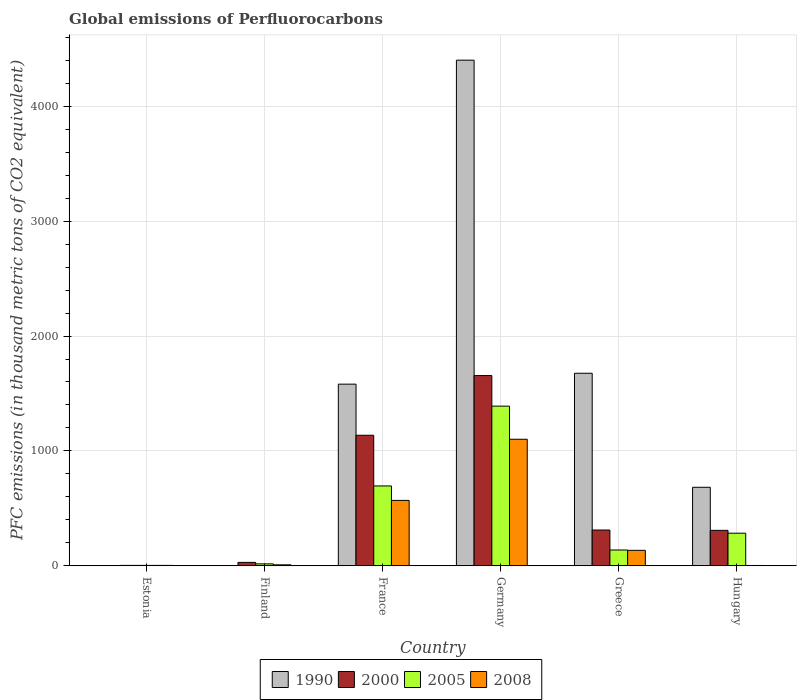How many bars are there on the 4th tick from the right?
Offer a terse response. 4. In how many cases, is the number of bars for a given country not equal to the number of legend labels?
Your response must be concise. 0. What is the global emissions of Perfluorocarbons in 2000 in Finland?
Your answer should be compact. 29.7. Across all countries, what is the maximum global emissions of Perfluorocarbons in 2008?
Offer a very short reply. 1101.4. Across all countries, what is the minimum global emissions of Perfluorocarbons in 2005?
Provide a short and direct response. 3.4. In which country was the global emissions of Perfluorocarbons in 2005 minimum?
Ensure brevity in your answer.  Estonia. What is the total global emissions of Perfluorocarbons in 2008 in the graph?
Your response must be concise. 1819.6. What is the difference between the global emissions of Perfluorocarbons in 2008 in France and that in Germany?
Provide a short and direct response. -532.2. What is the difference between the global emissions of Perfluorocarbons in 2000 in France and the global emissions of Perfluorocarbons in 1990 in Germany?
Make the answer very short. -3265. What is the average global emissions of Perfluorocarbons in 2005 per country?
Provide a succinct answer. 421.02. What is the difference between the global emissions of Perfluorocarbons of/in 2008 and global emissions of Perfluorocarbons of/in 2000 in Hungary?
Your response must be concise. -305.8. What is the ratio of the global emissions of Perfluorocarbons in 2005 in Germany to that in Greece?
Your answer should be very brief. 10.11. Is the global emissions of Perfluorocarbons in 2008 in Germany less than that in Hungary?
Give a very brief answer. No. Is the difference between the global emissions of Perfluorocarbons in 2008 in France and Greece greater than the difference between the global emissions of Perfluorocarbons in 2000 in France and Greece?
Make the answer very short. No. What is the difference between the highest and the second highest global emissions of Perfluorocarbons in 2005?
Keep it short and to the point. -1106. What is the difference between the highest and the lowest global emissions of Perfluorocarbons in 2000?
Keep it short and to the point. 1652.4. In how many countries, is the global emissions of Perfluorocarbons in 2000 greater than the average global emissions of Perfluorocarbons in 2000 taken over all countries?
Offer a terse response. 2. Is the sum of the global emissions of Perfluorocarbons in 2008 in Finland and France greater than the maximum global emissions of Perfluorocarbons in 2000 across all countries?
Your answer should be compact. No. What does the 2nd bar from the left in Hungary represents?
Your response must be concise. 2000. Is it the case that in every country, the sum of the global emissions of Perfluorocarbons in 2005 and global emissions of Perfluorocarbons in 2008 is greater than the global emissions of Perfluorocarbons in 2000?
Your answer should be very brief. No. Are all the bars in the graph horizontal?
Give a very brief answer. No. Are the values on the major ticks of Y-axis written in scientific E-notation?
Your answer should be compact. No. Does the graph contain any zero values?
Ensure brevity in your answer.  No. Does the graph contain grids?
Provide a succinct answer. Yes. How many legend labels are there?
Offer a very short reply. 4. What is the title of the graph?
Ensure brevity in your answer.  Global emissions of Perfluorocarbons. Does "1988" appear as one of the legend labels in the graph?
Give a very brief answer. No. What is the label or title of the Y-axis?
Ensure brevity in your answer.  PFC emissions (in thousand metric tons of CO2 equivalent). What is the PFC emissions (in thousand metric tons of CO2 equivalent) in 2000 in Estonia?
Your response must be concise. 3.5. What is the PFC emissions (in thousand metric tons of CO2 equivalent) in 2005 in Estonia?
Keep it short and to the point. 3.4. What is the PFC emissions (in thousand metric tons of CO2 equivalent) of 2008 in Estonia?
Keep it short and to the point. 3.4. What is the PFC emissions (in thousand metric tons of CO2 equivalent) of 2000 in Finland?
Offer a very short reply. 29.7. What is the PFC emissions (in thousand metric tons of CO2 equivalent) in 1990 in France?
Give a very brief answer. 1581.1. What is the PFC emissions (in thousand metric tons of CO2 equivalent) of 2000 in France?
Your answer should be compact. 1136.3. What is the PFC emissions (in thousand metric tons of CO2 equivalent) of 2005 in France?
Offer a very short reply. 695.1. What is the PFC emissions (in thousand metric tons of CO2 equivalent) of 2008 in France?
Ensure brevity in your answer.  569.2. What is the PFC emissions (in thousand metric tons of CO2 equivalent) in 1990 in Germany?
Offer a terse response. 4401.3. What is the PFC emissions (in thousand metric tons of CO2 equivalent) of 2000 in Germany?
Offer a very short reply. 1655.9. What is the PFC emissions (in thousand metric tons of CO2 equivalent) in 2005 in Germany?
Make the answer very short. 1389.7. What is the PFC emissions (in thousand metric tons of CO2 equivalent) of 2008 in Germany?
Provide a succinct answer. 1101.4. What is the PFC emissions (in thousand metric tons of CO2 equivalent) of 1990 in Greece?
Keep it short and to the point. 1675.9. What is the PFC emissions (in thousand metric tons of CO2 equivalent) of 2000 in Greece?
Provide a succinct answer. 311.3. What is the PFC emissions (in thousand metric tons of CO2 equivalent) of 2005 in Greece?
Ensure brevity in your answer.  137.5. What is the PFC emissions (in thousand metric tons of CO2 equivalent) in 2008 in Greece?
Offer a very short reply. 134.5. What is the PFC emissions (in thousand metric tons of CO2 equivalent) in 1990 in Hungary?
Your answer should be compact. 683.3. What is the PFC emissions (in thousand metric tons of CO2 equivalent) of 2000 in Hungary?
Make the answer very short. 308.5. What is the PFC emissions (in thousand metric tons of CO2 equivalent) in 2005 in Hungary?
Your answer should be very brief. 283.7. Across all countries, what is the maximum PFC emissions (in thousand metric tons of CO2 equivalent) in 1990?
Give a very brief answer. 4401.3. Across all countries, what is the maximum PFC emissions (in thousand metric tons of CO2 equivalent) in 2000?
Provide a succinct answer. 1655.9. Across all countries, what is the maximum PFC emissions (in thousand metric tons of CO2 equivalent) in 2005?
Provide a succinct answer. 1389.7. Across all countries, what is the maximum PFC emissions (in thousand metric tons of CO2 equivalent) of 2008?
Your answer should be very brief. 1101.4. Across all countries, what is the minimum PFC emissions (in thousand metric tons of CO2 equivalent) of 1990?
Offer a very short reply. 0.5. Across all countries, what is the minimum PFC emissions (in thousand metric tons of CO2 equivalent) of 2005?
Give a very brief answer. 3.4. Across all countries, what is the minimum PFC emissions (in thousand metric tons of CO2 equivalent) in 2008?
Make the answer very short. 2.7. What is the total PFC emissions (in thousand metric tons of CO2 equivalent) in 1990 in the graph?
Your answer should be compact. 8343.8. What is the total PFC emissions (in thousand metric tons of CO2 equivalent) in 2000 in the graph?
Keep it short and to the point. 3445.2. What is the total PFC emissions (in thousand metric tons of CO2 equivalent) of 2005 in the graph?
Make the answer very short. 2526.1. What is the total PFC emissions (in thousand metric tons of CO2 equivalent) of 2008 in the graph?
Make the answer very short. 1819.6. What is the difference between the PFC emissions (in thousand metric tons of CO2 equivalent) in 2000 in Estonia and that in Finland?
Make the answer very short. -26.2. What is the difference between the PFC emissions (in thousand metric tons of CO2 equivalent) of 1990 in Estonia and that in France?
Provide a succinct answer. -1580.6. What is the difference between the PFC emissions (in thousand metric tons of CO2 equivalent) of 2000 in Estonia and that in France?
Your response must be concise. -1132.8. What is the difference between the PFC emissions (in thousand metric tons of CO2 equivalent) in 2005 in Estonia and that in France?
Offer a terse response. -691.7. What is the difference between the PFC emissions (in thousand metric tons of CO2 equivalent) in 2008 in Estonia and that in France?
Offer a terse response. -565.8. What is the difference between the PFC emissions (in thousand metric tons of CO2 equivalent) in 1990 in Estonia and that in Germany?
Your answer should be very brief. -4400.8. What is the difference between the PFC emissions (in thousand metric tons of CO2 equivalent) of 2000 in Estonia and that in Germany?
Keep it short and to the point. -1652.4. What is the difference between the PFC emissions (in thousand metric tons of CO2 equivalent) of 2005 in Estonia and that in Germany?
Keep it short and to the point. -1386.3. What is the difference between the PFC emissions (in thousand metric tons of CO2 equivalent) in 2008 in Estonia and that in Germany?
Your answer should be compact. -1098. What is the difference between the PFC emissions (in thousand metric tons of CO2 equivalent) of 1990 in Estonia and that in Greece?
Ensure brevity in your answer.  -1675.4. What is the difference between the PFC emissions (in thousand metric tons of CO2 equivalent) in 2000 in Estonia and that in Greece?
Keep it short and to the point. -307.8. What is the difference between the PFC emissions (in thousand metric tons of CO2 equivalent) in 2005 in Estonia and that in Greece?
Provide a succinct answer. -134.1. What is the difference between the PFC emissions (in thousand metric tons of CO2 equivalent) in 2008 in Estonia and that in Greece?
Your answer should be very brief. -131.1. What is the difference between the PFC emissions (in thousand metric tons of CO2 equivalent) of 1990 in Estonia and that in Hungary?
Offer a terse response. -682.8. What is the difference between the PFC emissions (in thousand metric tons of CO2 equivalent) in 2000 in Estonia and that in Hungary?
Provide a short and direct response. -305. What is the difference between the PFC emissions (in thousand metric tons of CO2 equivalent) of 2005 in Estonia and that in Hungary?
Your answer should be very brief. -280.3. What is the difference between the PFC emissions (in thousand metric tons of CO2 equivalent) of 1990 in Finland and that in France?
Ensure brevity in your answer.  -1579.4. What is the difference between the PFC emissions (in thousand metric tons of CO2 equivalent) in 2000 in Finland and that in France?
Your answer should be compact. -1106.6. What is the difference between the PFC emissions (in thousand metric tons of CO2 equivalent) of 2005 in Finland and that in France?
Your answer should be very brief. -678.4. What is the difference between the PFC emissions (in thousand metric tons of CO2 equivalent) in 2008 in Finland and that in France?
Make the answer very short. -560.8. What is the difference between the PFC emissions (in thousand metric tons of CO2 equivalent) in 1990 in Finland and that in Germany?
Give a very brief answer. -4399.6. What is the difference between the PFC emissions (in thousand metric tons of CO2 equivalent) in 2000 in Finland and that in Germany?
Provide a short and direct response. -1626.2. What is the difference between the PFC emissions (in thousand metric tons of CO2 equivalent) in 2005 in Finland and that in Germany?
Give a very brief answer. -1373. What is the difference between the PFC emissions (in thousand metric tons of CO2 equivalent) in 2008 in Finland and that in Germany?
Your answer should be compact. -1093. What is the difference between the PFC emissions (in thousand metric tons of CO2 equivalent) in 1990 in Finland and that in Greece?
Ensure brevity in your answer.  -1674.2. What is the difference between the PFC emissions (in thousand metric tons of CO2 equivalent) in 2000 in Finland and that in Greece?
Your answer should be compact. -281.6. What is the difference between the PFC emissions (in thousand metric tons of CO2 equivalent) of 2005 in Finland and that in Greece?
Your response must be concise. -120.8. What is the difference between the PFC emissions (in thousand metric tons of CO2 equivalent) of 2008 in Finland and that in Greece?
Offer a terse response. -126.1. What is the difference between the PFC emissions (in thousand metric tons of CO2 equivalent) of 1990 in Finland and that in Hungary?
Provide a succinct answer. -681.6. What is the difference between the PFC emissions (in thousand metric tons of CO2 equivalent) in 2000 in Finland and that in Hungary?
Your response must be concise. -278.8. What is the difference between the PFC emissions (in thousand metric tons of CO2 equivalent) in 2005 in Finland and that in Hungary?
Provide a succinct answer. -267. What is the difference between the PFC emissions (in thousand metric tons of CO2 equivalent) in 1990 in France and that in Germany?
Give a very brief answer. -2820.2. What is the difference between the PFC emissions (in thousand metric tons of CO2 equivalent) of 2000 in France and that in Germany?
Make the answer very short. -519.6. What is the difference between the PFC emissions (in thousand metric tons of CO2 equivalent) in 2005 in France and that in Germany?
Ensure brevity in your answer.  -694.6. What is the difference between the PFC emissions (in thousand metric tons of CO2 equivalent) of 2008 in France and that in Germany?
Offer a very short reply. -532.2. What is the difference between the PFC emissions (in thousand metric tons of CO2 equivalent) of 1990 in France and that in Greece?
Offer a terse response. -94.8. What is the difference between the PFC emissions (in thousand metric tons of CO2 equivalent) of 2000 in France and that in Greece?
Offer a very short reply. 825. What is the difference between the PFC emissions (in thousand metric tons of CO2 equivalent) in 2005 in France and that in Greece?
Offer a very short reply. 557.6. What is the difference between the PFC emissions (in thousand metric tons of CO2 equivalent) of 2008 in France and that in Greece?
Provide a succinct answer. 434.7. What is the difference between the PFC emissions (in thousand metric tons of CO2 equivalent) in 1990 in France and that in Hungary?
Offer a terse response. 897.8. What is the difference between the PFC emissions (in thousand metric tons of CO2 equivalent) of 2000 in France and that in Hungary?
Your answer should be compact. 827.8. What is the difference between the PFC emissions (in thousand metric tons of CO2 equivalent) of 2005 in France and that in Hungary?
Your response must be concise. 411.4. What is the difference between the PFC emissions (in thousand metric tons of CO2 equivalent) in 2008 in France and that in Hungary?
Give a very brief answer. 566.5. What is the difference between the PFC emissions (in thousand metric tons of CO2 equivalent) in 1990 in Germany and that in Greece?
Your response must be concise. 2725.4. What is the difference between the PFC emissions (in thousand metric tons of CO2 equivalent) of 2000 in Germany and that in Greece?
Your answer should be compact. 1344.6. What is the difference between the PFC emissions (in thousand metric tons of CO2 equivalent) in 2005 in Germany and that in Greece?
Provide a succinct answer. 1252.2. What is the difference between the PFC emissions (in thousand metric tons of CO2 equivalent) of 2008 in Germany and that in Greece?
Offer a terse response. 966.9. What is the difference between the PFC emissions (in thousand metric tons of CO2 equivalent) in 1990 in Germany and that in Hungary?
Your answer should be very brief. 3718. What is the difference between the PFC emissions (in thousand metric tons of CO2 equivalent) of 2000 in Germany and that in Hungary?
Your answer should be compact. 1347.4. What is the difference between the PFC emissions (in thousand metric tons of CO2 equivalent) of 2005 in Germany and that in Hungary?
Your answer should be very brief. 1106. What is the difference between the PFC emissions (in thousand metric tons of CO2 equivalent) of 2008 in Germany and that in Hungary?
Offer a very short reply. 1098.7. What is the difference between the PFC emissions (in thousand metric tons of CO2 equivalent) in 1990 in Greece and that in Hungary?
Your answer should be compact. 992.6. What is the difference between the PFC emissions (in thousand metric tons of CO2 equivalent) of 2005 in Greece and that in Hungary?
Your answer should be very brief. -146.2. What is the difference between the PFC emissions (in thousand metric tons of CO2 equivalent) of 2008 in Greece and that in Hungary?
Your answer should be very brief. 131.8. What is the difference between the PFC emissions (in thousand metric tons of CO2 equivalent) of 1990 in Estonia and the PFC emissions (in thousand metric tons of CO2 equivalent) of 2000 in Finland?
Provide a succinct answer. -29.2. What is the difference between the PFC emissions (in thousand metric tons of CO2 equivalent) of 1990 in Estonia and the PFC emissions (in thousand metric tons of CO2 equivalent) of 2005 in Finland?
Ensure brevity in your answer.  -16.2. What is the difference between the PFC emissions (in thousand metric tons of CO2 equivalent) in 2000 in Estonia and the PFC emissions (in thousand metric tons of CO2 equivalent) in 2005 in Finland?
Keep it short and to the point. -13.2. What is the difference between the PFC emissions (in thousand metric tons of CO2 equivalent) of 1990 in Estonia and the PFC emissions (in thousand metric tons of CO2 equivalent) of 2000 in France?
Your response must be concise. -1135.8. What is the difference between the PFC emissions (in thousand metric tons of CO2 equivalent) in 1990 in Estonia and the PFC emissions (in thousand metric tons of CO2 equivalent) in 2005 in France?
Make the answer very short. -694.6. What is the difference between the PFC emissions (in thousand metric tons of CO2 equivalent) of 1990 in Estonia and the PFC emissions (in thousand metric tons of CO2 equivalent) of 2008 in France?
Provide a succinct answer. -568.7. What is the difference between the PFC emissions (in thousand metric tons of CO2 equivalent) in 2000 in Estonia and the PFC emissions (in thousand metric tons of CO2 equivalent) in 2005 in France?
Your response must be concise. -691.6. What is the difference between the PFC emissions (in thousand metric tons of CO2 equivalent) of 2000 in Estonia and the PFC emissions (in thousand metric tons of CO2 equivalent) of 2008 in France?
Provide a short and direct response. -565.7. What is the difference between the PFC emissions (in thousand metric tons of CO2 equivalent) of 2005 in Estonia and the PFC emissions (in thousand metric tons of CO2 equivalent) of 2008 in France?
Ensure brevity in your answer.  -565.8. What is the difference between the PFC emissions (in thousand metric tons of CO2 equivalent) of 1990 in Estonia and the PFC emissions (in thousand metric tons of CO2 equivalent) of 2000 in Germany?
Offer a very short reply. -1655.4. What is the difference between the PFC emissions (in thousand metric tons of CO2 equivalent) of 1990 in Estonia and the PFC emissions (in thousand metric tons of CO2 equivalent) of 2005 in Germany?
Give a very brief answer. -1389.2. What is the difference between the PFC emissions (in thousand metric tons of CO2 equivalent) in 1990 in Estonia and the PFC emissions (in thousand metric tons of CO2 equivalent) in 2008 in Germany?
Offer a terse response. -1100.9. What is the difference between the PFC emissions (in thousand metric tons of CO2 equivalent) in 2000 in Estonia and the PFC emissions (in thousand metric tons of CO2 equivalent) in 2005 in Germany?
Offer a very short reply. -1386.2. What is the difference between the PFC emissions (in thousand metric tons of CO2 equivalent) of 2000 in Estonia and the PFC emissions (in thousand metric tons of CO2 equivalent) of 2008 in Germany?
Offer a very short reply. -1097.9. What is the difference between the PFC emissions (in thousand metric tons of CO2 equivalent) of 2005 in Estonia and the PFC emissions (in thousand metric tons of CO2 equivalent) of 2008 in Germany?
Give a very brief answer. -1098. What is the difference between the PFC emissions (in thousand metric tons of CO2 equivalent) of 1990 in Estonia and the PFC emissions (in thousand metric tons of CO2 equivalent) of 2000 in Greece?
Offer a terse response. -310.8. What is the difference between the PFC emissions (in thousand metric tons of CO2 equivalent) in 1990 in Estonia and the PFC emissions (in thousand metric tons of CO2 equivalent) in 2005 in Greece?
Provide a short and direct response. -137. What is the difference between the PFC emissions (in thousand metric tons of CO2 equivalent) of 1990 in Estonia and the PFC emissions (in thousand metric tons of CO2 equivalent) of 2008 in Greece?
Provide a succinct answer. -134. What is the difference between the PFC emissions (in thousand metric tons of CO2 equivalent) in 2000 in Estonia and the PFC emissions (in thousand metric tons of CO2 equivalent) in 2005 in Greece?
Make the answer very short. -134. What is the difference between the PFC emissions (in thousand metric tons of CO2 equivalent) of 2000 in Estonia and the PFC emissions (in thousand metric tons of CO2 equivalent) of 2008 in Greece?
Offer a very short reply. -131. What is the difference between the PFC emissions (in thousand metric tons of CO2 equivalent) in 2005 in Estonia and the PFC emissions (in thousand metric tons of CO2 equivalent) in 2008 in Greece?
Offer a very short reply. -131.1. What is the difference between the PFC emissions (in thousand metric tons of CO2 equivalent) in 1990 in Estonia and the PFC emissions (in thousand metric tons of CO2 equivalent) in 2000 in Hungary?
Provide a short and direct response. -308. What is the difference between the PFC emissions (in thousand metric tons of CO2 equivalent) of 1990 in Estonia and the PFC emissions (in thousand metric tons of CO2 equivalent) of 2005 in Hungary?
Your answer should be compact. -283.2. What is the difference between the PFC emissions (in thousand metric tons of CO2 equivalent) of 1990 in Estonia and the PFC emissions (in thousand metric tons of CO2 equivalent) of 2008 in Hungary?
Your answer should be compact. -2.2. What is the difference between the PFC emissions (in thousand metric tons of CO2 equivalent) of 2000 in Estonia and the PFC emissions (in thousand metric tons of CO2 equivalent) of 2005 in Hungary?
Your answer should be compact. -280.2. What is the difference between the PFC emissions (in thousand metric tons of CO2 equivalent) in 1990 in Finland and the PFC emissions (in thousand metric tons of CO2 equivalent) in 2000 in France?
Make the answer very short. -1134.6. What is the difference between the PFC emissions (in thousand metric tons of CO2 equivalent) in 1990 in Finland and the PFC emissions (in thousand metric tons of CO2 equivalent) in 2005 in France?
Your answer should be very brief. -693.4. What is the difference between the PFC emissions (in thousand metric tons of CO2 equivalent) of 1990 in Finland and the PFC emissions (in thousand metric tons of CO2 equivalent) of 2008 in France?
Provide a short and direct response. -567.5. What is the difference between the PFC emissions (in thousand metric tons of CO2 equivalent) of 2000 in Finland and the PFC emissions (in thousand metric tons of CO2 equivalent) of 2005 in France?
Offer a terse response. -665.4. What is the difference between the PFC emissions (in thousand metric tons of CO2 equivalent) of 2000 in Finland and the PFC emissions (in thousand metric tons of CO2 equivalent) of 2008 in France?
Ensure brevity in your answer.  -539.5. What is the difference between the PFC emissions (in thousand metric tons of CO2 equivalent) of 2005 in Finland and the PFC emissions (in thousand metric tons of CO2 equivalent) of 2008 in France?
Your answer should be very brief. -552.5. What is the difference between the PFC emissions (in thousand metric tons of CO2 equivalent) of 1990 in Finland and the PFC emissions (in thousand metric tons of CO2 equivalent) of 2000 in Germany?
Keep it short and to the point. -1654.2. What is the difference between the PFC emissions (in thousand metric tons of CO2 equivalent) in 1990 in Finland and the PFC emissions (in thousand metric tons of CO2 equivalent) in 2005 in Germany?
Offer a terse response. -1388. What is the difference between the PFC emissions (in thousand metric tons of CO2 equivalent) of 1990 in Finland and the PFC emissions (in thousand metric tons of CO2 equivalent) of 2008 in Germany?
Ensure brevity in your answer.  -1099.7. What is the difference between the PFC emissions (in thousand metric tons of CO2 equivalent) of 2000 in Finland and the PFC emissions (in thousand metric tons of CO2 equivalent) of 2005 in Germany?
Make the answer very short. -1360. What is the difference between the PFC emissions (in thousand metric tons of CO2 equivalent) in 2000 in Finland and the PFC emissions (in thousand metric tons of CO2 equivalent) in 2008 in Germany?
Offer a very short reply. -1071.7. What is the difference between the PFC emissions (in thousand metric tons of CO2 equivalent) of 2005 in Finland and the PFC emissions (in thousand metric tons of CO2 equivalent) of 2008 in Germany?
Your answer should be compact. -1084.7. What is the difference between the PFC emissions (in thousand metric tons of CO2 equivalent) of 1990 in Finland and the PFC emissions (in thousand metric tons of CO2 equivalent) of 2000 in Greece?
Ensure brevity in your answer.  -309.6. What is the difference between the PFC emissions (in thousand metric tons of CO2 equivalent) of 1990 in Finland and the PFC emissions (in thousand metric tons of CO2 equivalent) of 2005 in Greece?
Your answer should be very brief. -135.8. What is the difference between the PFC emissions (in thousand metric tons of CO2 equivalent) of 1990 in Finland and the PFC emissions (in thousand metric tons of CO2 equivalent) of 2008 in Greece?
Keep it short and to the point. -132.8. What is the difference between the PFC emissions (in thousand metric tons of CO2 equivalent) in 2000 in Finland and the PFC emissions (in thousand metric tons of CO2 equivalent) in 2005 in Greece?
Your answer should be very brief. -107.8. What is the difference between the PFC emissions (in thousand metric tons of CO2 equivalent) of 2000 in Finland and the PFC emissions (in thousand metric tons of CO2 equivalent) of 2008 in Greece?
Give a very brief answer. -104.8. What is the difference between the PFC emissions (in thousand metric tons of CO2 equivalent) of 2005 in Finland and the PFC emissions (in thousand metric tons of CO2 equivalent) of 2008 in Greece?
Provide a succinct answer. -117.8. What is the difference between the PFC emissions (in thousand metric tons of CO2 equivalent) in 1990 in Finland and the PFC emissions (in thousand metric tons of CO2 equivalent) in 2000 in Hungary?
Provide a succinct answer. -306.8. What is the difference between the PFC emissions (in thousand metric tons of CO2 equivalent) of 1990 in Finland and the PFC emissions (in thousand metric tons of CO2 equivalent) of 2005 in Hungary?
Offer a terse response. -282. What is the difference between the PFC emissions (in thousand metric tons of CO2 equivalent) in 2000 in Finland and the PFC emissions (in thousand metric tons of CO2 equivalent) in 2005 in Hungary?
Your response must be concise. -254. What is the difference between the PFC emissions (in thousand metric tons of CO2 equivalent) of 2000 in Finland and the PFC emissions (in thousand metric tons of CO2 equivalent) of 2008 in Hungary?
Ensure brevity in your answer.  27. What is the difference between the PFC emissions (in thousand metric tons of CO2 equivalent) in 1990 in France and the PFC emissions (in thousand metric tons of CO2 equivalent) in 2000 in Germany?
Your answer should be compact. -74.8. What is the difference between the PFC emissions (in thousand metric tons of CO2 equivalent) of 1990 in France and the PFC emissions (in thousand metric tons of CO2 equivalent) of 2005 in Germany?
Your answer should be compact. 191.4. What is the difference between the PFC emissions (in thousand metric tons of CO2 equivalent) in 1990 in France and the PFC emissions (in thousand metric tons of CO2 equivalent) in 2008 in Germany?
Offer a terse response. 479.7. What is the difference between the PFC emissions (in thousand metric tons of CO2 equivalent) in 2000 in France and the PFC emissions (in thousand metric tons of CO2 equivalent) in 2005 in Germany?
Your answer should be compact. -253.4. What is the difference between the PFC emissions (in thousand metric tons of CO2 equivalent) of 2000 in France and the PFC emissions (in thousand metric tons of CO2 equivalent) of 2008 in Germany?
Give a very brief answer. 34.9. What is the difference between the PFC emissions (in thousand metric tons of CO2 equivalent) in 2005 in France and the PFC emissions (in thousand metric tons of CO2 equivalent) in 2008 in Germany?
Provide a short and direct response. -406.3. What is the difference between the PFC emissions (in thousand metric tons of CO2 equivalent) in 1990 in France and the PFC emissions (in thousand metric tons of CO2 equivalent) in 2000 in Greece?
Provide a short and direct response. 1269.8. What is the difference between the PFC emissions (in thousand metric tons of CO2 equivalent) in 1990 in France and the PFC emissions (in thousand metric tons of CO2 equivalent) in 2005 in Greece?
Make the answer very short. 1443.6. What is the difference between the PFC emissions (in thousand metric tons of CO2 equivalent) of 1990 in France and the PFC emissions (in thousand metric tons of CO2 equivalent) of 2008 in Greece?
Make the answer very short. 1446.6. What is the difference between the PFC emissions (in thousand metric tons of CO2 equivalent) of 2000 in France and the PFC emissions (in thousand metric tons of CO2 equivalent) of 2005 in Greece?
Offer a very short reply. 998.8. What is the difference between the PFC emissions (in thousand metric tons of CO2 equivalent) of 2000 in France and the PFC emissions (in thousand metric tons of CO2 equivalent) of 2008 in Greece?
Offer a terse response. 1001.8. What is the difference between the PFC emissions (in thousand metric tons of CO2 equivalent) in 2005 in France and the PFC emissions (in thousand metric tons of CO2 equivalent) in 2008 in Greece?
Your answer should be compact. 560.6. What is the difference between the PFC emissions (in thousand metric tons of CO2 equivalent) of 1990 in France and the PFC emissions (in thousand metric tons of CO2 equivalent) of 2000 in Hungary?
Provide a short and direct response. 1272.6. What is the difference between the PFC emissions (in thousand metric tons of CO2 equivalent) in 1990 in France and the PFC emissions (in thousand metric tons of CO2 equivalent) in 2005 in Hungary?
Ensure brevity in your answer.  1297.4. What is the difference between the PFC emissions (in thousand metric tons of CO2 equivalent) in 1990 in France and the PFC emissions (in thousand metric tons of CO2 equivalent) in 2008 in Hungary?
Offer a terse response. 1578.4. What is the difference between the PFC emissions (in thousand metric tons of CO2 equivalent) in 2000 in France and the PFC emissions (in thousand metric tons of CO2 equivalent) in 2005 in Hungary?
Your answer should be very brief. 852.6. What is the difference between the PFC emissions (in thousand metric tons of CO2 equivalent) of 2000 in France and the PFC emissions (in thousand metric tons of CO2 equivalent) of 2008 in Hungary?
Give a very brief answer. 1133.6. What is the difference between the PFC emissions (in thousand metric tons of CO2 equivalent) of 2005 in France and the PFC emissions (in thousand metric tons of CO2 equivalent) of 2008 in Hungary?
Your response must be concise. 692.4. What is the difference between the PFC emissions (in thousand metric tons of CO2 equivalent) of 1990 in Germany and the PFC emissions (in thousand metric tons of CO2 equivalent) of 2000 in Greece?
Keep it short and to the point. 4090. What is the difference between the PFC emissions (in thousand metric tons of CO2 equivalent) in 1990 in Germany and the PFC emissions (in thousand metric tons of CO2 equivalent) in 2005 in Greece?
Ensure brevity in your answer.  4263.8. What is the difference between the PFC emissions (in thousand metric tons of CO2 equivalent) of 1990 in Germany and the PFC emissions (in thousand metric tons of CO2 equivalent) of 2008 in Greece?
Keep it short and to the point. 4266.8. What is the difference between the PFC emissions (in thousand metric tons of CO2 equivalent) in 2000 in Germany and the PFC emissions (in thousand metric tons of CO2 equivalent) in 2005 in Greece?
Make the answer very short. 1518.4. What is the difference between the PFC emissions (in thousand metric tons of CO2 equivalent) of 2000 in Germany and the PFC emissions (in thousand metric tons of CO2 equivalent) of 2008 in Greece?
Make the answer very short. 1521.4. What is the difference between the PFC emissions (in thousand metric tons of CO2 equivalent) in 2005 in Germany and the PFC emissions (in thousand metric tons of CO2 equivalent) in 2008 in Greece?
Keep it short and to the point. 1255.2. What is the difference between the PFC emissions (in thousand metric tons of CO2 equivalent) of 1990 in Germany and the PFC emissions (in thousand metric tons of CO2 equivalent) of 2000 in Hungary?
Offer a very short reply. 4092.8. What is the difference between the PFC emissions (in thousand metric tons of CO2 equivalent) in 1990 in Germany and the PFC emissions (in thousand metric tons of CO2 equivalent) in 2005 in Hungary?
Make the answer very short. 4117.6. What is the difference between the PFC emissions (in thousand metric tons of CO2 equivalent) in 1990 in Germany and the PFC emissions (in thousand metric tons of CO2 equivalent) in 2008 in Hungary?
Your response must be concise. 4398.6. What is the difference between the PFC emissions (in thousand metric tons of CO2 equivalent) in 2000 in Germany and the PFC emissions (in thousand metric tons of CO2 equivalent) in 2005 in Hungary?
Offer a very short reply. 1372.2. What is the difference between the PFC emissions (in thousand metric tons of CO2 equivalent) in 2000 in Germany and the PFC emissions (in thousand metric tons of CO2 equivalent) in 2008 in Hungary?
Offer a very short reply. 1653.2. What is the difference between the PFC emissions (in thousand metric tons of CO2 equivalent) of 2005 in Germany and the PFC emissions (in thousand metric tons of CO2 equivalent) of 2008 in Hungary?
Offer a terse response. 1387. What is the difference between the PFC emissions (in thousand metric tons of CO2 equivalent) of 1990 in Greece and the PFC emissions (in thousand metric tons of CO2 equivalent) of 2000 in Hungary?
Provide a succinct answer. 1367.4. What is the difference between the PFC emissions (in thousand metric tons of CO2 equivalent) of 1990 in Greece and the PFC emissions (in thousand metric tons of CO2 equivalent) of 2005 in Hungary?
Offer a terse response. 1392.2. What is the difference between the PFC emissions (in thousand metric tons of CO2 equivalent) in 1990 in Greece and the PFC emissions (in thousand metric tons of CO2 equivalent) in 2008 in Hungary?
Offer a terse response. 1673.2. What is the difference between the PFC emissions (in thousand metric tons of CO2 equivalent) of 2000 in Greece and the PFC emissions (in thousand metric tons of CO2 equivalent) of 2005 in Hungary?
Provide a succinct answer. 27.6. What is the difference between the PFC emissions (in thousand metric tons of CO2 equivalent) in 2000 in Greece and the PFC emissions (in thousand metric tons of CO2 equivalent) in 2008 in Hungary?
Offer a very short reply. 308.6. What is the difference between the PFC emissions (in thousand metric tons of CO2 equivalent) of 2005 in Greece and the PFC emissions (in thousand metric tons of CO2 equivalent) of 2008 in Hungary?
Keep it short and to the point. 134.8. What is the average PFC emissions (in thousand metric tons of CO2 equivalent) in 1990 per country?
Offer a very short reply. 1390.63. What is the average PFC emissions (in thousand metric tons of CO2 equivalent) in 2000 per country?
Provide a succinct answer. 574.2. What is the average PFC emissions (in thousand metric tons of CO2 equivalent) of 2005 per country?
Provide a short and direct response. 421.02. What is the average PFC emissions (in thousand metric tons of CO2 equivalent) in 2008 per country?
Your answer should be compact. 303.27. What is the difference between the PFC emissions (in thousand metric tons of CO2 equivalent) in 1990 and PFC emissions (in thousand metric tons of CO2 equivalent) in 2005 in Estonia?
Your answer should be compact. -2.9. What is the difference between the PFC emissions (in thousand metric tons of CO2 equivalent) in 1990 and PFC emissions (in thousand metric tons of CO2 equivalent) in 2008 in Estonia?
Your answer should be compact. -2.9. What is the difference between the PFC emissions (in thousand metric tons of CO2 equivalent) of 2005 and PFC emissions (in thousand metric tons of CO2 equivalent) of 2008 in Estonia?
Give a very brief answer. 0. What is the difference between the PFC emissions (in thousand metric tons of CO2 equivalent) in 1990 and PFC emissions (in thousand metric tons of CO2 equivalent) in 2000 in Finland?
Make the answer very short. -28. What is the difference between the PFC emissions (in thousand metric tons of CO2 equivalent) of 1990 and PFC emissions (in thousand metric tons of CO2 equivalent) of 2005 in Finland?
Make the answer very short. -15. What is the difference between the PFC emissions (in thousand metric tons of CO2 equivalent) in 2000 and PFC emissions (in thousand metric tons of CO2 equivalent) in 2008 in Finland?
Ensure brevity in your answer.  21.3. What is the difference between the PFC emissions (in thousand metric tons of CO2 equivalent) of 1990 and PFC emissions (in thousand metric tons of CO2 equivalent) of 2000 in France?
Keep it short and to the point. 444.8. What is the difference between the PFC emissions (in thousand metric tons of CO2 equivalent) of 1990 and PFC emissions (in thousand metric tons of CO2 equivalent) of 2005 in France?
Your answer should be very brief. 886. What is the difference between the PFC emissions (in thousand metric tons of CO2 equivalent) in 1990 and PFC emissions (in thousand metric tons of CO2 equivalent) in 2008 in France?
Provide a succinct answer. 1011.9. What is the difference between the PFC emissions (in thousand metric tons of CO2 equivalent) in 2000 and PFC emissions (in thousand metric tons of CO2 equivalent) in 2005 in France?
Your response must be concise. 441.2. What is the difference between the PFC emissions (in thousand metric tons of CO2 equivalent) in 2000 and PFC emissions (in thousand metric tons of CO2 equivalent) in 2008 in France?
Your response must be concise. 567.1. What is the difference between the PFC emissions (in thousand metric tons of CO2 equivalent) of 2005 and PFC emissions (in thousand metric tons of CO2 equivalent) of 2008 in France?
Your response must be concise. 125.9. What is the difference between the PFC emissions (in thousand metric tons of CO2 equivalent) in 1990 and PFC emissions (in thousand metric tons of CO2 equivalent) in 2000 in Germany?
Keep it short and to the point. 2745.4. What is the difference between the PFC emissions (in thousand metric tons of CO2 equivalent) of 1990 and PFC emissions (in thousand metric tons of CO2 equivalent) of 2005 in Germany?
Your response must be concise. 3011.6. What is the difference between the PFC emissions (in thousand metric tons of CO2 equivalent) of 1990 and PFC emissions (in thousand metric tons of CO2 equivalent) of 2008 in Germany?
Your answer should be very brief. 3299.9. What is the difference between the PFC emissions (in thousand metric tons of CO2 equivalent) in 2000 and PFC emissions (in thousand metric tons of CO2 equivalent) in 2005 in Germany?
Provide a succinct answer. 266.2. What is the difference between the PFC emissions (in thousand metric tons of CO2 equivalent) in 2000 and PFC emissions (in thousand metric tons of CO2 equivalent) in 2008 in Germany?
Your answer should be very brief. 554.5. What is the difference between the PFC emissions (in thousand metric tons of CO2 equivalent) of 2005 and PFC emissions (in thousand metric tons of CO2 equivalent) of 2008 in Germany?
Provide a succinct answer. 288.3. What is the difference between the PFC emissions (in thousand metric tons of CO2 equivalent) of 1990 and PFC emissions (in thousand metric tons of CO2 equivalent) of 2000 in Greece?
Your response must be concise. 1364.6. What is the difference between the PFC emissions (in thousand metric tons of CO2 equivalent) of 1990 and PFC emissions (in thousand metric tons of CO2 equivalent) of 2005 in Greece?
Your answer should be very brief. 1538.4. What is the difference between the PFC emissions (in thousand metric tons of CO2 equivalent) of 1990 and PFC emissions (in thousand metric tons of CO2 equivalent) of 2008 in Greece?
Offer a very short reply. 1541.4. What is the difference between the PFC emissions (in thousand metric tons of CO2 equivalent) of 2000 and PFC emissions (in thousand metric tons of CO2 equivalent) of 2005 in Greece?
Give a very brief answer. 173.8. What is the difference between the PFC emissions (in thousand metric tons of CO2 equivalent) in 2000 and PFC emissions (in thousand metric tons of CO2 equivalent) in 2008 in Greece?
Offer a terse response. 176.8. What is the difference between the PFC emissions (in thousand metric tons of CO2 equivalent) in 2005 and PFC emissions (in thousand metric tons of CO2 equivalent) in 2008 in Greece?
Offer a very short reply. 3. What is the difference between the PFC emissions (in thousand metric tons of CO2 equivalent) in 1990 and PFC emissions (in thousand metric tons of CO2 equivalent) in 2000 in Hungary?
Your response must be concise. 374.8. What is the difference between the PFC emissions (in thousand metric tons of CO2 equivalent) in 1990 and PFC emissions (in thousand metric tons of CO2 equivalent) in 2005 in Hungary?
Give a very brief answer. 399.6. What is the difference between the PFC emissions (in thousand metric tons of CO2 equivalent) in 1990 and PFC emissions (in thousand metric tons of CO2 equivalent) in 2008 in Hungary?
Provide a succinct answer. 680.6. What is the difference between the PFC emissions (in thousand metric tons of CO2 equivalent) in 2000 and PFC emissions (in thousand metric tons of CO2 equivalent) in 2005 in Hungary?
Provide a succinct answer. 24.8. What is the difference between the PFC emissions (in thousand metric tons of CO2 equivalent) in 2000 and PFC emissions (in thousand metric tons of CO2 equivalent) in 2008 in Hungary?
Offer a terse response. 305.8. What is the difference between the PFC emissions (in thousand metric tons of CO2 equivalent) of 2005 and PFC emissions (in thousand metric tons of CO2 equivalent) of 2008 in Hungary?
Your response must be concise. 281. What is the ratio of the PFC emissions (in thousand metric tons of CO2 equivalent) in 1990 in Estonia to that in Finland?
Give a very brief answer. 0.29. What is the ratio of the PFC emissions (in thousand metric tons of CO2 equivalent) in 2000 in Estonia to that in Finland?
Your answer should be compact. 0.12. What is the ratio of the PFC emissions (in thousand metric tons of CO2 equivalent) of 2005 in Estonia to that in Finland?
Your answer should be compact. 0.2. What is the ratio of the PFC emissions (in thousand metric tons of CO2 equivalent) in 2008 in Estonia to that in Finland?
Make the answer very short. 0.4. What is the ratio of the PFC emissions (in thousand metric tons of CO2 equivalent) in 1990 in Estonia to that in France?
Provide a succinct answer. 0. What is the ratio of the PFC emissions (in thousand metric tons of CO2 equivalent) in 2000 in Estonia to that in France?
Ensure brevity in your answer.  0. What is the ratio of the PFC emissions (in thousand metric tons of CO2 equivalent) of 2005 in Estonia to that in France?
Your answer should be very brief. 0. What is the ratio of the PFC emissions (in thousand metric tons of CO2 equivalent) in 2008 in Estonia to that in France?
Offer a terse response. 0.01. What is the ratio of the PFC emissions (in thousand metric tons of CO2 equivalent) of 1990 in Estonia to that in Germany?
Provide a short and direct response. 0. What is the ratio of the PFC emissions (in thousand metric tons of CO2 equivalent) in 2000 in Estonia to that in Germany?
Provide a short and direct response. 0. What is the ratio of the PFC emissions (in thousand metric tons of CO2 equivalent) in 2005 in Estonia to that in Germany?
Give a very brief answer. 0. What is the ratio of the PFC emissions (in thousand metric tons of CO2 equivalent) of 2008 in Estonia to that in Germany?
Offer a very short reply. 0. What is the ratio of the PFC emissions (in thousand metric tons of CO2 equivalent) in 2000 in Estonia to that in Greece?
Keep it short and to the point. 0.01. What is the ratio of the PFC emissions (in thousand metric tons of CO2 equivalent) in 2005 in Estonia to that in Greece?
Ensure brevity in your answer.  0.02. What is the ratio of the PFC emissions (in thousand metric tons of CO2 equivalent) in 2008 in Estonia to that in Greece?
Your answer should be compact. 0.03. What is the ratio of the PFC emissions (in thousand metric tons of CO2 equivalent) in 1990 in Estonia to that in Hungary?
Make the answer very short. 0. What is the ratio of the PFC emissions (in thousand metric tons of CO2 equivalent) in 2000 in Estonia to that in Hungary?
Offer a very short reply. 0.01. What is the ratio of the PFC emissions (in thousand metric tons of CO2 equivalent) of 2005 in Estonia to that in Hungary?
Your response must be concise. 0.01. What is the ratio of the PFC emissions (in thousand metric tons of CO2 equivalent) of 2008 in Estonia to that in Hungary?
Your answer should be compact. 1.26. What is the ratio of the PFC emissions (in thousand metric tons of CO2 equivalent) in 1990 in Finland to that in France?
Your answer should be very brief. 0. What is the ratio of the PFC emissions (in thousand metric tons of CO2 equivalent) of 2000 in Finland to that in France?
Your answer should be very brief. 0.03. What is the ratio of the PFC emissions (in thousand metric tons of CO2 equivalent) in 2005 in Finland to that in France?
Keep it short and to the point. 0.02. What is the ratio of the PFC emissions (in thousand metric tons of CO2 equivalent) of 2008 in Finland to that in France?
Ensure brevity in your answer.  0.01. What is the ratio of the PFC emissions (in thousand metric tons of CO2 equivalent) of 2000 in Finland to that in Germany?
Ensure brevity in your answer.  0.02. What is the ratio of the PFC emissions (in thousand metric tons of CO2 equivalent) of 2005 in Finland to that in Germany?
Ensure brevity in your answer.  0.01. What is the ratio of the PFC emissions (in thousand metric tons of CO2 equivalent) in 2008 in Finland to that in Germany?
Give a very brief answer. 0.01. What is the ratio of the PFC emissions (in thousand metric tons of CO2 equivalent) of 2000 in Finland to that in Greece?
Provide a succinct answer. 0.1. What is the ratio of the PFC emissions (in thousand metric tons of CO2 equivalent) in 2005 in Finland to that in Greece?
Keep it short and to the point. 0.12. What is the ratio of the PFC emissions (in thousand metric tons of CO2 equivalent) in 2008 in Finland to that in Greece?
Make the answer very short. 0.06. What is the ratio of the PFC emissions (in thousand metric tons of CO2 equivalent) in 1990 in Finland to that in Hungary?
Ensure brevity in your answer.  0. What is the ratio of the PFC emissions (in thousand metric tons of CO2 equivalent) in 2000 in Finland to that in Hungary?
Make the answer very short. 0.1. What is the ratio of the PFC emissions (in thousand metric tons of CO2 equivalent) in 2005 in Finland to that in Hungary?
Provide a succinct answer. 0.06. What is the ratio of the PFC emissions (in thousand metric tons of CO2 equivalent) in 2008 in Finland to that in Hungary?
Make the answer very short. 3.11. What is the ratio of the PFC emissions (in thousand metric tons of CO2 equivalent) in 1990 in France to that in Germany?
Offer a very short reply. 0.36. What is the ratio of the PFC emissions (in thousand metric tons of CO2 equivalent) in 2000 in France to that in Germany?
Offer a very short reply. 0.69. What is the ratio of the PFC emissions (in thousand metric tons of CO2 equivalent) of 2005 in France to that in Germany?
Provide a short and direct response. 0.5. What is the ratio of the PFC emissions (in thousand metric tons of CO2 equivalent) of 2008 in France to that in Germany?
Your answer should be very brief. 0.52. What is the ratio of the PFC emissions (in thousand metric tons of CO2 equivalent) in 1990 in France to that in Greece?
Your answer should be very brief. 0.94. What is the ratio of the PFC emissions (in thousand metric tons of CO2 equivalent) in 2000 in France to that in Greece?
Your answer should be very brief. 3.65. What is the ratio of the PFC emissions (in thousand metric tons of CO2 equivalent) in 2005 in France to that in Greece?
Make the answer very short. 5.06. What is the ratio of the PFC emissions (in thousand metric tons of CO2 equivalent) of 2008 in France to that in Greece?
Ensure brevity in your answer.  4.23. What is the ratio of the PFC emissions (in thousand metric tons of CO2 equivalent) in 1990 in France to that in Hungary?
Your answer should be very brief. 2.31. What is the ratio of the PFC emissions (in thousand metric tons of CO2 equivalent) of 2000 in France to that in Hungary?
Provide a succinct answer. 3.68. What is the ratio of the PFC emissions (in thousand metric tons of CO2 equivalent) in 2005 in France to that in Hungary?
Make the answer very short. 2.45. What is the ratio of the PFC emissions (in thousand metric tons of CO2 equivalent) of 2008 in France to that in Hungary?
Ensure brevity in your answer.  210.81. What is the ratio of the PFC emissions (in thousand metric tons of CO2 equivalent) of 1990 in Germany to that in Greece?
Offer a very short reply. 2.63. What is the ratio of the PFC emissions (in thousand metric tons of CO2 equivalent) in 2000 in Germany to that in Greece?
Provide a short and direct response. 5.32. What is the ratio of the PFC emissions (in thousand metric tons of CO2 equivalent) in 2005 in Germany to that in Greece?
Provide a short and direct response. 10.11. What is the ratio of the PFC emissions (in thousand metric tons of CO2 equivalent) of 2008 in Germany to that in Greece?
Your response must be concise. 8.19. What is the ratio of the PFC emissions (in thousand metric tons of CO2 equivalent) of 1990 in Germany to that in Hungary?
Provide a succinct answer. 6.44. What is the ratio of the PFC emissions (in thousand metric tons of CO2 equivalent) in 2000 in Germany to that in Hungary?
Offer a very short reply. 5.37. What is the ratio of the PFC emissions (in thousand metric tons of CO2 equivalent) in 2005 in Germany to that in Hungary?
Your answer should be very brief. 4.9. What is the ratio of the PFC emissions (in thousand metric tons of CO2 equivalent) of 2008 in Germany to that in Hungary?
Ensure brevity in your answer.  407.93. What is the ratio of the PFC emissions (in thousand metric tons of CO2 equivalent) of 1990 in Greece to that in Hungary?
Your answer should be compact. 2.45. What is the ratio of the PFC emissions (in thousand metric tons of CO2 equivalent) of 2000 in Greece to that in Hungary?
Your response must be concise. 1.01. What is the ratio of the PFC emissions (in thousand metric tons of CO2 equivalent) of 2005 in Greece to that in Hungary?
Ensure brevity in your answer.  0.48. What is the ratio of the PFC emissions (in thousand metric tons of CO2 equivalent) of 2008 in Greece to that in Hungary?
Provide a short and direct response. 49.81. What is the difference between the highest and the second highest PFC emissions (in thousand metric tons of CO2 equivalent) of 1990?
Make the answer very short. 2725.4. What is the difference between the highest and the second highest PFC emissions (in thousand metric tons of CO2 equivalent) of 2000?
Your response must be concise. 519.6. What is the difference between the highest and the second highest PFC emissions (in thousand metric tons of CO2 equivalent) of 2005?
Your response must be concise. 694.6. What is the difference between the highest and the second highest PFC emissions (in thousand metric tons of CO2 equivalent) of 2008?
Your answer should be very brief. 532.2. What is the difference between the highest and the lowest PFC emissions (in thousand metric tons of CO2 equivalent) of 1990?
Provide a succinct answer. 4400.8. What is the difference between the highest and the lowest PFC emissions (in thousand metric tons of CO2 equivalent) of 2000?
Keep it short and to the point. 1652.4. What is the difference between the highest and the lowest PFC emissions (in thousand metric tons of CO2 equivalent) of 2005?
Offer a very short reply. 1386.3. What is the difference between the highest and the lowest PFC emissions (in thousand metric tons of CO2 equivalent) in 2008?
Make the answer very short. 1098.7. 